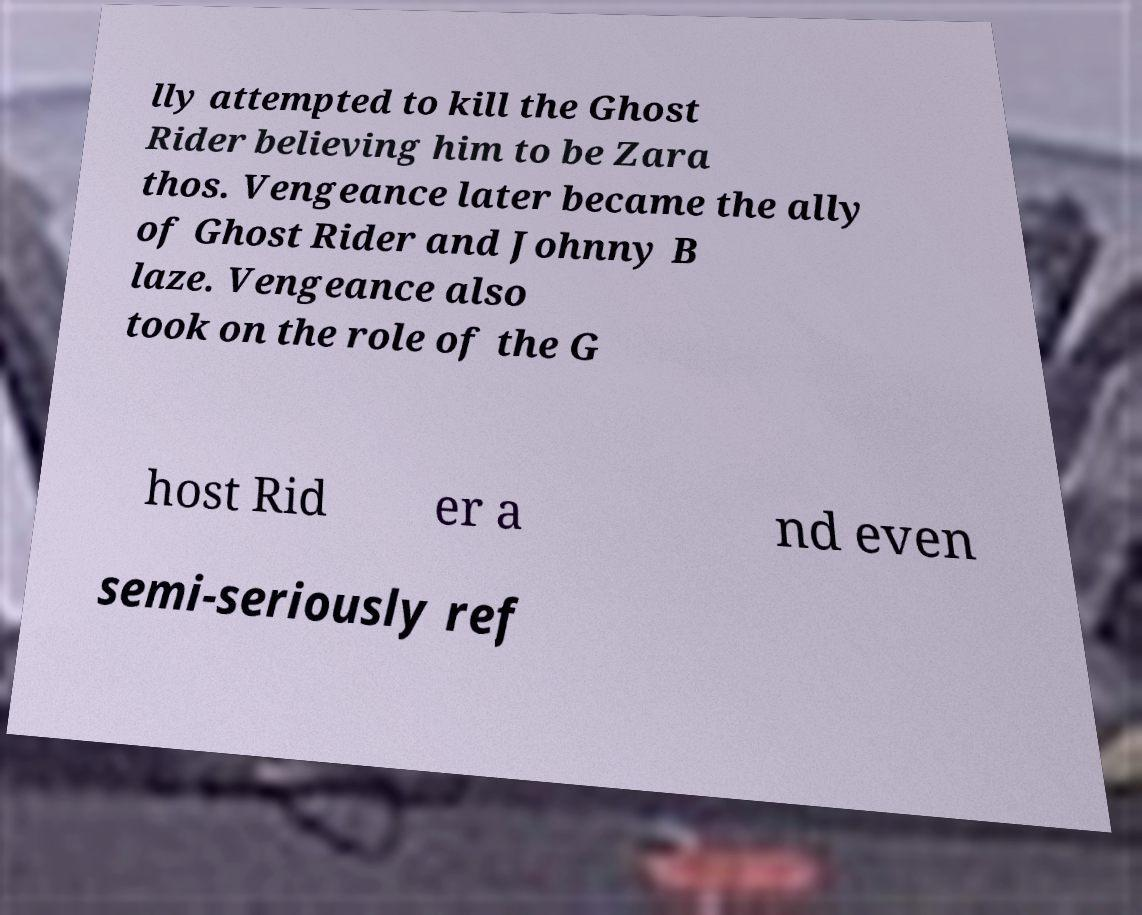There's text embedded in this image that I need extracted. Can you transcribe it verbatim? lly attempted to kill the Ghost Rider believing him to be Zara thos. Vengeance later became the ally of Ghost Rider and Johnny B laze. Vengeance also took on the role of the G host Rid er a nd even semi-seriously ref 